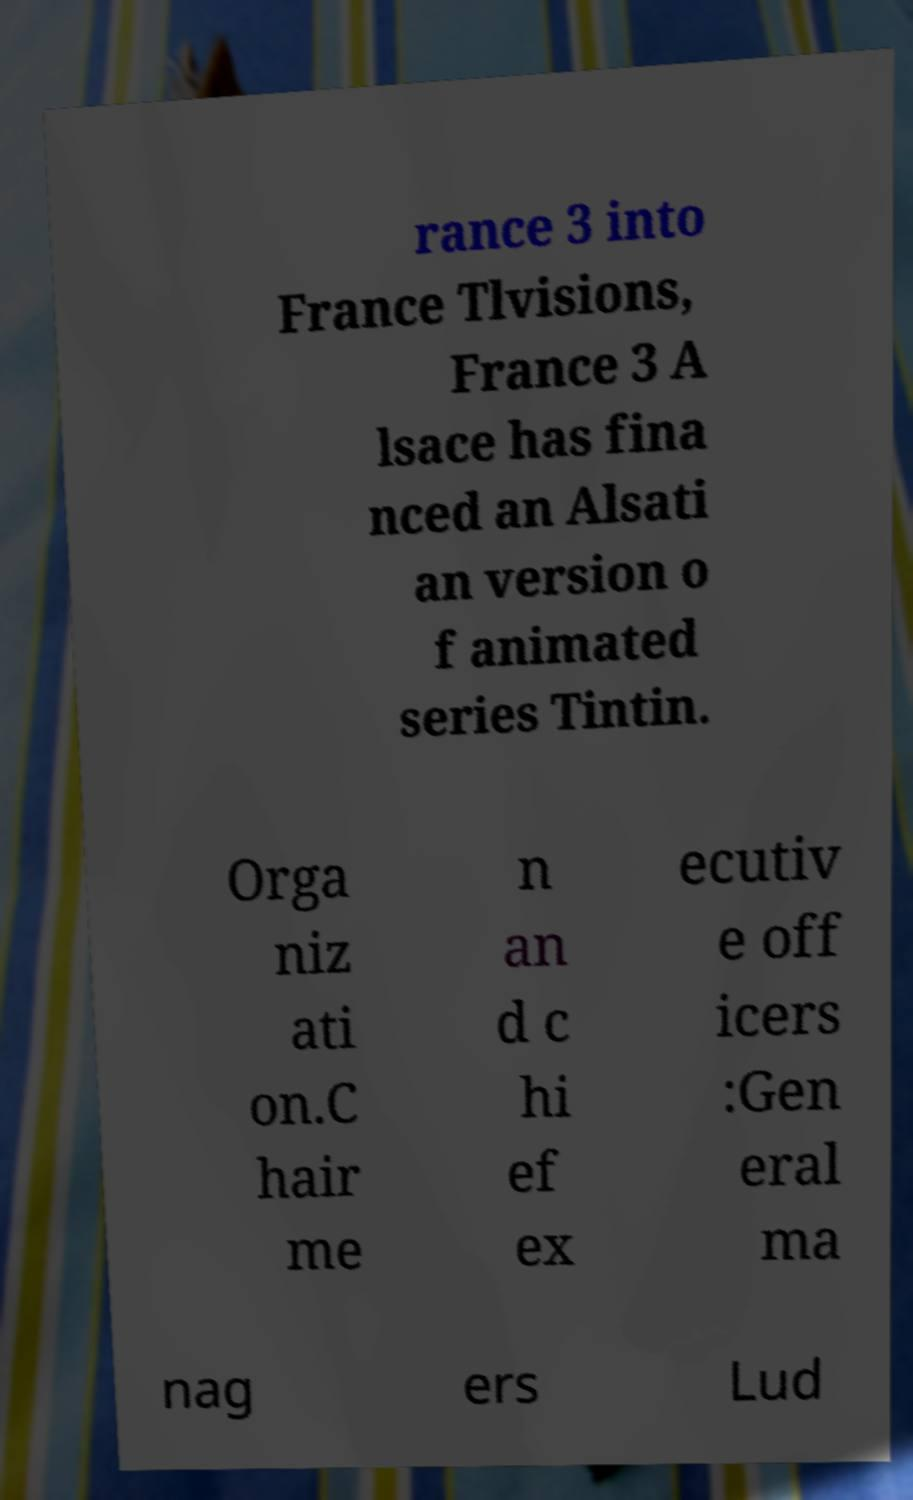There's text embedded in this image that I need extracted. Can you transcribe it verbatim? rance 3 into France Tlvisions, France 3 A lsace has fina nced an Alsati an version o f animated series Tintin. Orga niz ati on.C hair me n an d c hi ef ex ecutiv e off icers :Gen eral ma nag ers Lud 